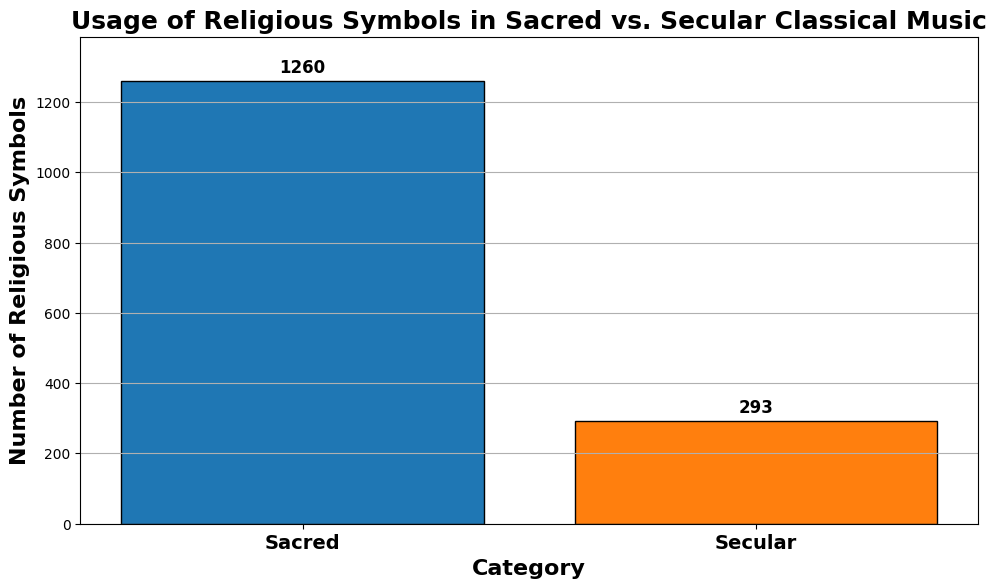What are the total number of religious symbols across both categories? To find the total number across both categories, add the values for Sacred and Secular. Sacred has a total of 1260 (150+200+180+160+190+170+210), and Secular has a total of 293 (30+50+40+35+45+38+55). So the total is 1260 + 293.
Answer: 1553 Which category has the higher number of religious symbols? Compare the sum of religious symbols in Sacred and Secular categories. Sacred has 1260, and Secular has 293.
Answer: Sacred By how much do sacred compositions exceed secular compositions in the use of religious symbols? Subtract the total number of religious symbols in Secular (293) from Sacred (1260).
Answer: 967 What is the average number of religious symbols used in secular compositions? There are 7 values in Secular: (30+50+40+35+45+38+55). The sum is 293. Divide by 7.
Answer: 41.86 What is the median number of religious symbols used in sacred compositions? Arrange the Sacred values (150, 160, 170, 180, 190, 200, 210) in ascending order. The median is the middle number in this list.
Answer: 180 What is the color of the bar representing the secular compositions? Identify the color of the bar in the chart that represents Secular compositions.
Answer: Orange What is the difference in the number of religious symbols between the highest and lowest bars? Identify the height of the highest bar (Sacred, 1260) and the lowest bar (Secular, 293). Subtract the smaller from the larger.
Answer: 967 Which category has its bar with a height of more than 1000 religious symbols? Identify the bar(s) exceeding 1000 by their height and categorization.
Answer: Sacred What is the sum of the religious symbols from the two categories where the smallest values from each are considered? The smallest value in Sacred is 150, and in Secular is 30. Add them together.
Answer: 180 If the number of religious symbols in secular compositions was doubled, how would that total compare to the current total in sacred compositions? Doubling the total for Secular gives 293 * 2 = 586. Compare this to the total for Sacred, which is 1260.
Answer: Less 